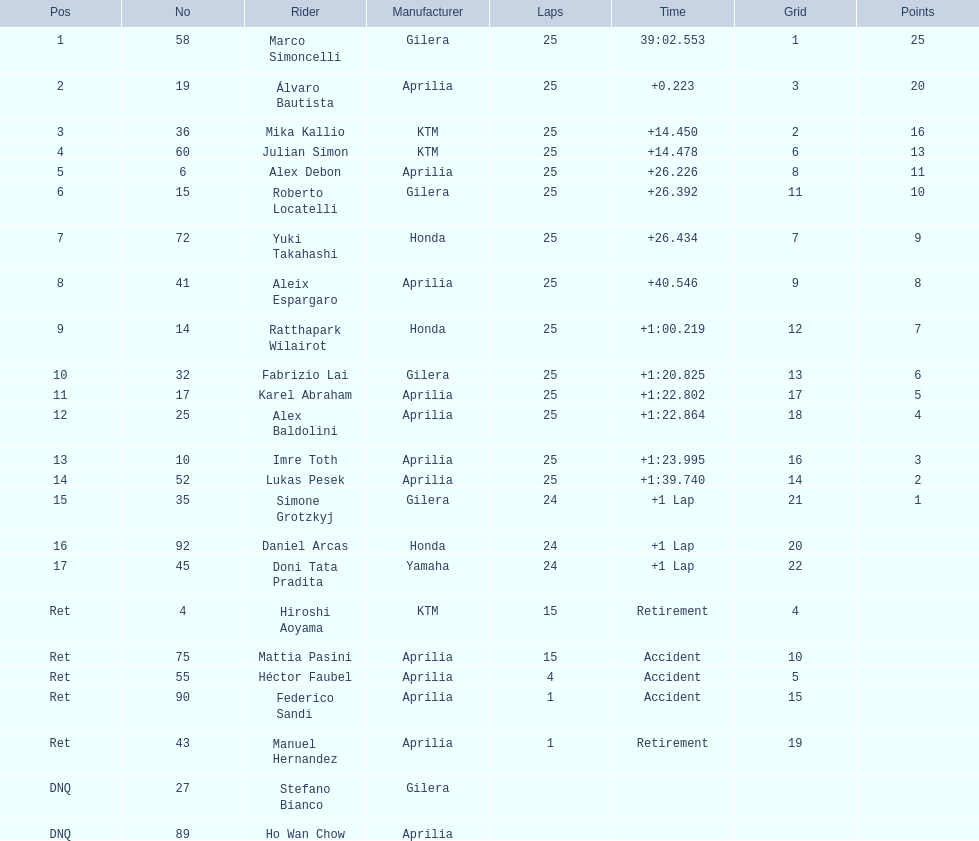Write the full table. {'header': ['Pos', 'No', 'Rider', 'Manufacturer', 'Laps', 'Time', 'Grid', 'Points'], 'rows': [['1', '58', 'Marco Simoncelli', 'Gilera', '25', '39:02.553', '1', '25'], ['2', '19', 'Álvaro Bautista', 'Aprilia', '25', '+0.223', '3', '20'], ['3', '36', 'Mika Kallio', 'KTM', '25', '+14.450', '2', '16'], ['4', '60', 'Julian Simon', 'KTM', '25', '+14.478', '6', '13'], ['5', '6', 'Alex Debon', 'Aprilia', '25', '+26.226', '8', '11'], ['6', '15', 'Roberto Locatelli', 'Gilera', '25', '+26.392', '11', '10'], ['7', '72', 'Yuki Takahashi', 'Honda', '25', '+26.434', '7', '9'], ['8', '41', 'Aleix Espargaro', 'Aprilia', '25', '+40.546', '9', '8'], ['9', '14', 'Ratthapark Wilairot', 'Honda', '25', '+1:00.219', '12', '7'], ['10', '32', 'Fabrizio Lai', 'Gilera', '25', '+1:20.825', '13', '6'], ['11', '17', 'Karel Abraham', 'Aprilia', '25', '+1:22.802', '17', '5'], ['12', '25', 'Alex Baldolini', 'Aprilia', '25', '+1:22.864', '18', '4'], ['13', '10', 'Imre Toth', 'Aprilia', '25', '+1:23.995', '16', '3'], ['14', '52', 'Lukas Pesek', 'Aprilia', '25', '+1:39.740', '14', '2'], ['15', '35', 'Simone Grotzkyj', 'Gilera', '24', '+1 Lap', '21', '1'], ['16', '92', 'Daniel Arcas', 'Honda', '24', '+1 Lap', '20', ''], ['17', '45', 'Doni Tata Pradita', 'Yamaha', '24', '+1 Lap', '22', ''], ['Ret', '4', 'Hiroshi Aoyama', 'KTM', '15', 'Retirement', '4', ''], ['Ret', '75', 'Mattia Pasini', 'Aprilia', '15', 'Accident', '10', ''], ['Ret', '55', 'Héctor Faubel', 'Aprilia', '4', 'Accident', '5', ''], ['Ret', '90', 'Federico Sandi', 'Aprilia', '1', 'Accident', '15', ''], ['Ret', '43', 'Manuel Hernandez', 'Aprilia', '1', 'Retirement', '19', ''], ['DNQ', '27', 'Stefano Bianco', 'Gilera', '', '', '', ''], ['DNQ', '89', 'Ho Wan Chow', 'Aprilia', '', '', '', '']]} Who were the riders involved? Marco Simoncelli, Álvaro Bautista, Mika Kallio, Julian Simon, Alex Debon, Roberto Locatelli, Yuki Takahashi, Aleix Espargaro, Ratthapark Wilairot, Fabrizio Lai, Karel Abraham, Alex Baldolini, Imre Toth, Lukas Pesek, Simone Grotzkyj, Daniel Arcas, Doni Tata Pradita, Hiroshi Aoyama, Mattia Pasini, Héctor Faubel, Federico Sandi, Manuel Hernandez, Stefano Bianco, Ho Wan Chow. What was the number of laps they completed? 25, 25, 25, 25, 25, 25, 25, 25, 25, 25, 25, 25, 25, 25, 24, 24, 24, 15, 15, 4, 1, 1, , . Who had more laps between marco simoncelli and hiroshi aoyama? Marco Simoncelli. 